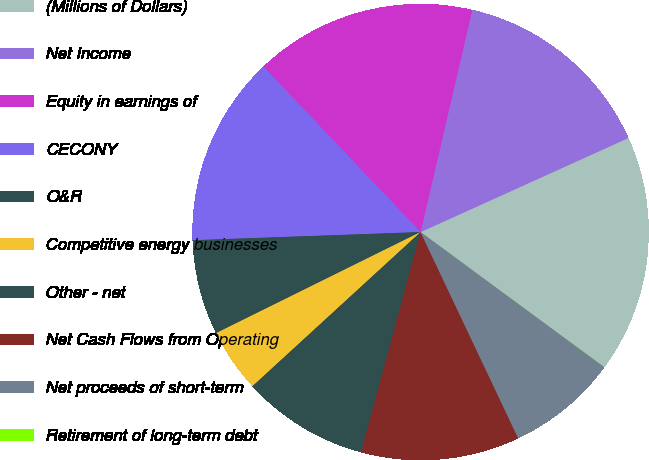<chart> <loc_0><loc_0><loc_500><loc_500><pie_chart><fcel>(Millions of Dollars)<fcel>Net Income<fcel>Equity in earnings of<fcel>CECONY<fcel>O&R<fcel>Competitive energy businesses<fcel>Other - net<fcel>Net Cash Flows from Operating<fcel>Net proceeds of short-term<fcel>Retirement of long-term debt<nl><fcel>16.85%<fcel>14.6%<fcel>15.73%<fcel>13.48%<fcel>6.74%<fcel>4.5%<fcel>8.99%<fcel>11.24%<fcel>7.87%<fcel>0.01%<nl></chart> 